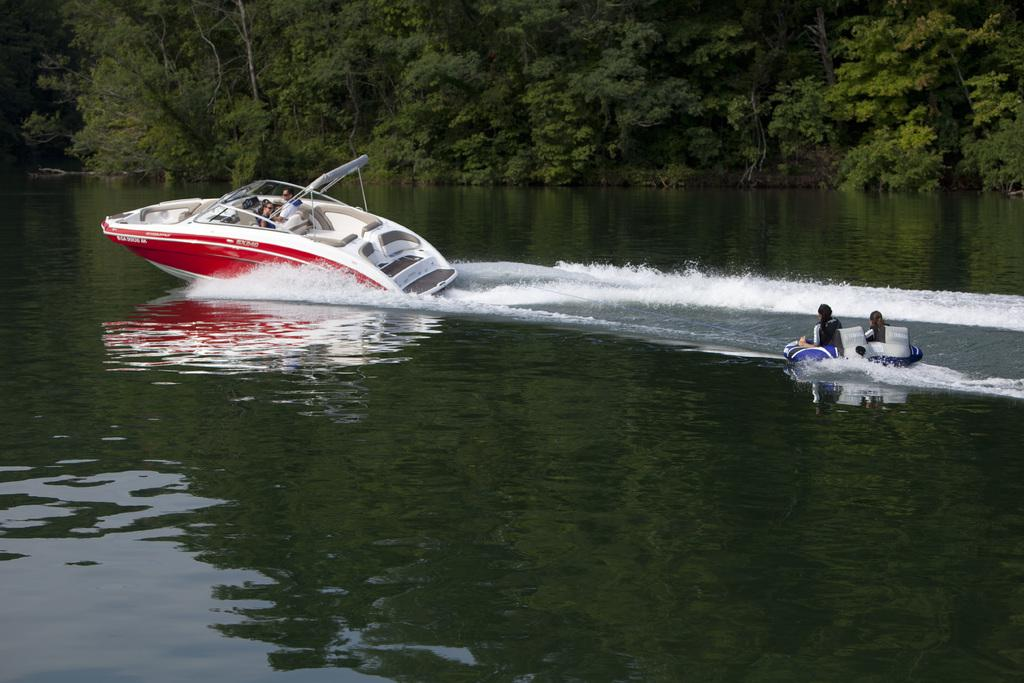What are the people in the image doing? The people in the image are on boats. What can be seen in the background of the image? There are trees in the background of the image. What is visible at the bottom of the image? There is water visible at the bottom of the image. What type of comb is being used by the kitten in the image? There is no kitten or comb present in the image. What type of system is being used to control the boats in the image? The image does not show any system for controlling the boats; it only shows people on the boats. 